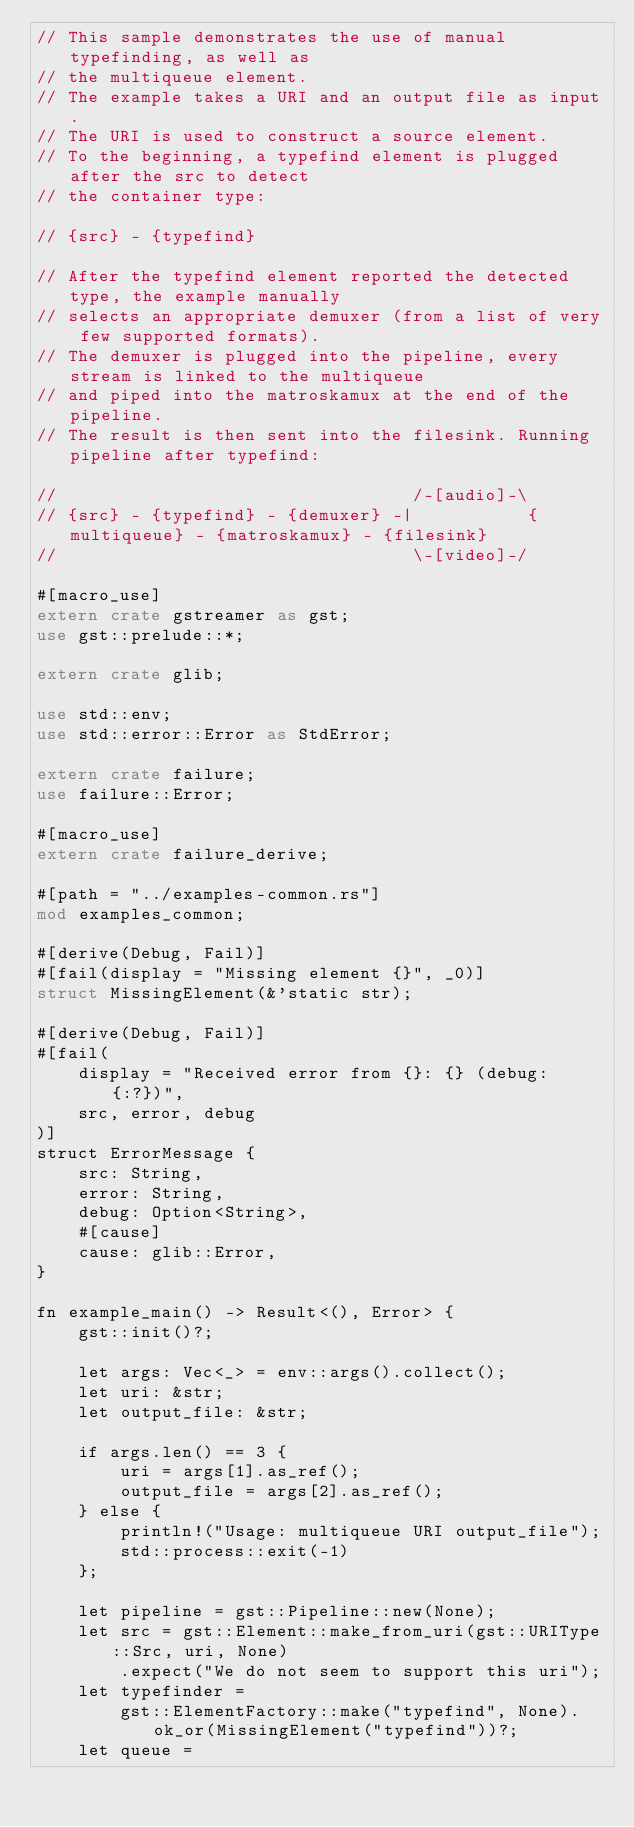<code> <loc_0><loc_0><loc_500><loc_500><_Rust_>// This sample demonstrates the use of manual typefinding, as well as
// the multiqueue element.
// The example takes a URI and an output file as input.
// The URI is used to construct a source element.
// To the beginning, a typefind element is plugged after the src to detect
// the container type:

// {src} - {typefind}

// After the typefind element reported the detected type, the example manually
// selects an appropriate demuxer (from a list of very few supported formats).
// The demuxer is plugged into the pipeline, every stream is linked to the multiqueue
// and piped into the matroskamux at the end of the pipeline.
// The result is then sent into the filesink. Running pipeline after typefind:

//                                  /-[audio]-\
// {src} - {typefind} - {demuxer} -|           {multiqueue} - {matroskamux} - {filesink}
//                                  \-[video]-/

#[macro_use]
extern crate gstreamer as gst;
use gst::prelude::*;

extern crate glib;

use std::env;
use std::error::Error as StdError;

extern crate failure;
use failure::Error;

#[macro_use]
extern crate failure_derive;

#[path = "../examples-common.rs"]
mod examples_common;

#[derive(Debug, Fail)]
#[fail(display = "Missing element {}", _0)]
struct MissingElement(&'static str);

#[derive(Debug, Fail)]
#[fail(
    display = "Received error from {}: {} (debug: {:?})",
    src, error, debug
)]
struct ErrorMessage {
    src: String,
    error: String,
    debug: Option<String>,
    #[cause]
    cause: glib::Error,
}

fn example_main() -> Result<(), Error> {
    gst::init()?;

    let args: Vec<_> = env::args().collect();
    let uri: &str;
    let output_file: &str;

    if args.len() == 3 {
        uri = args[1].as_ref();
        output_file = args[2].as_ref();
    } else {
        println!("Usage: multiqueue URI output_file");
        std::process::exit(-1)
    };

    let pipeline = gst::Pipeline::new(None);
    let src = gst::Element::make_from_uri(gst::URIType::Src, uri, None)
        .expect("We do not seem to support this uri");
    let typefinder =
        gst::ElementFactory::make("typefind", None).ok_or(MissingElement("typefind"))?;
    let queue =</code> 